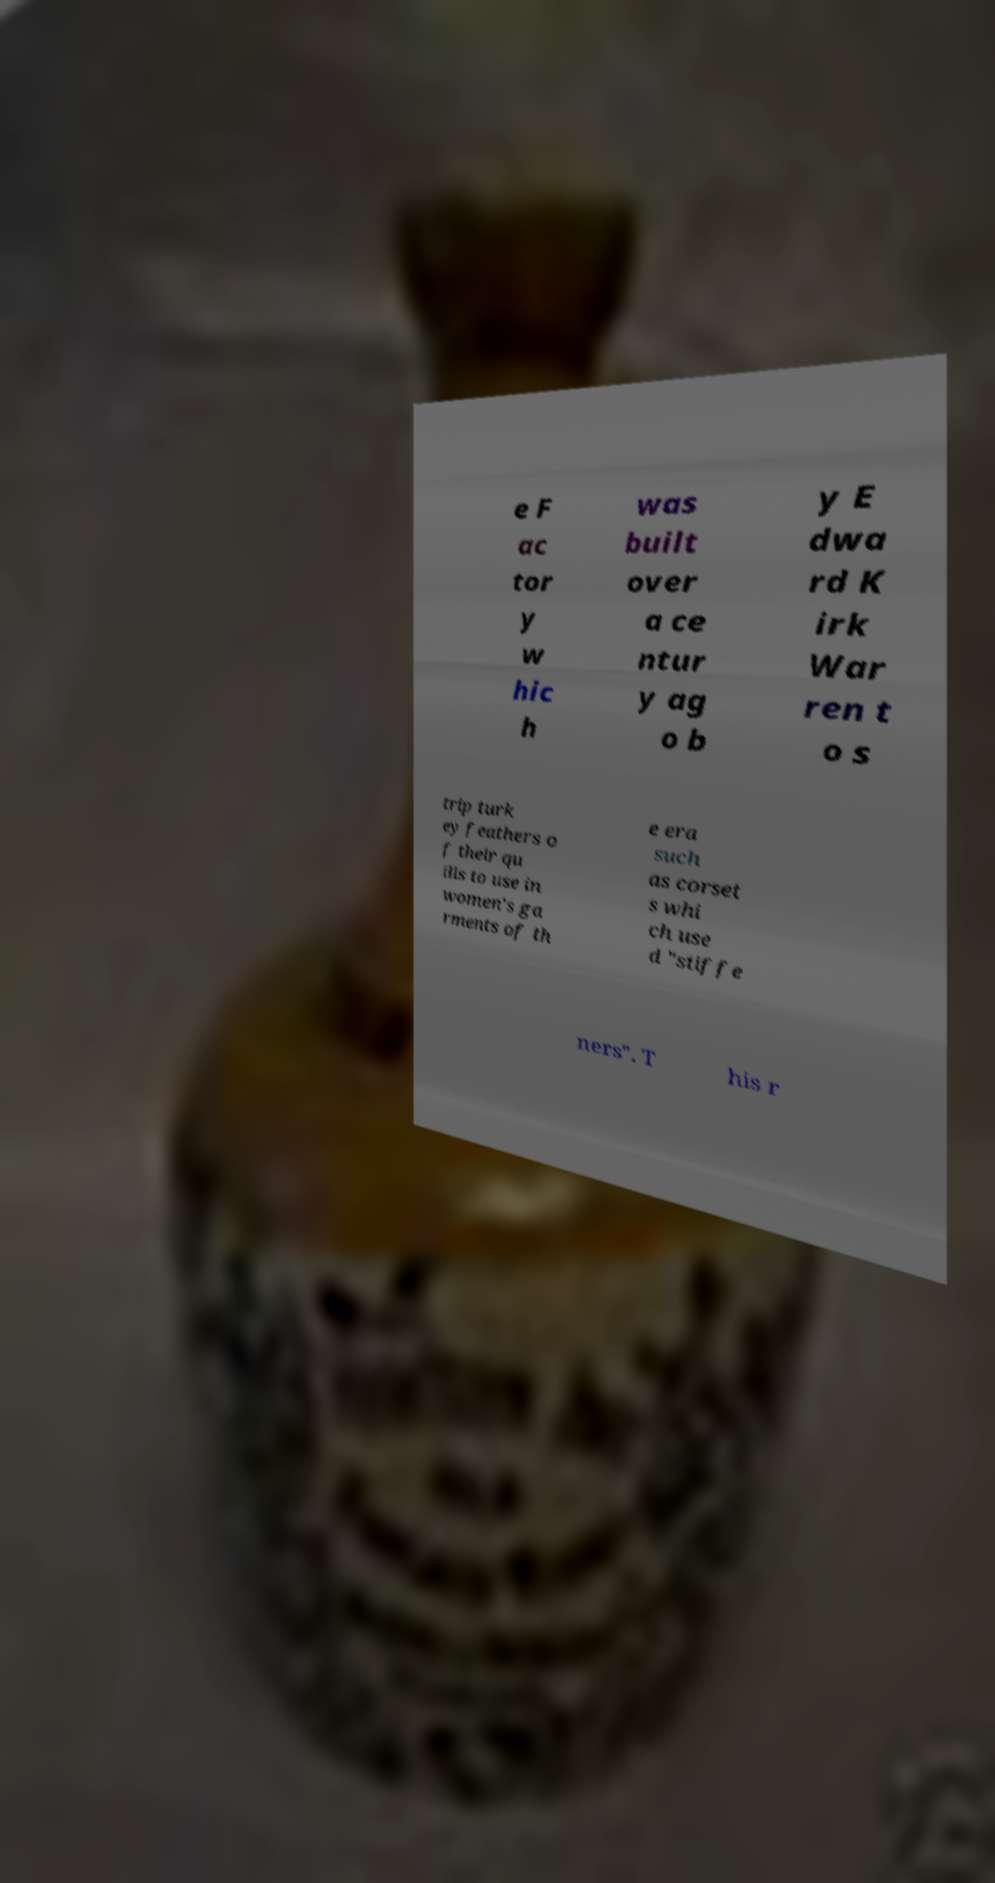Could you assist in decoding the text presented in this image and type it out clearly? e F ac tor y w hic h was built over a ce ntur y ag o b y E dwa rd K irk War ren t o s trip turk ey feathers o f their qu ills to use in women's ga rments of th e era such as corset s whi ch use d "stiffe ners". T his r 